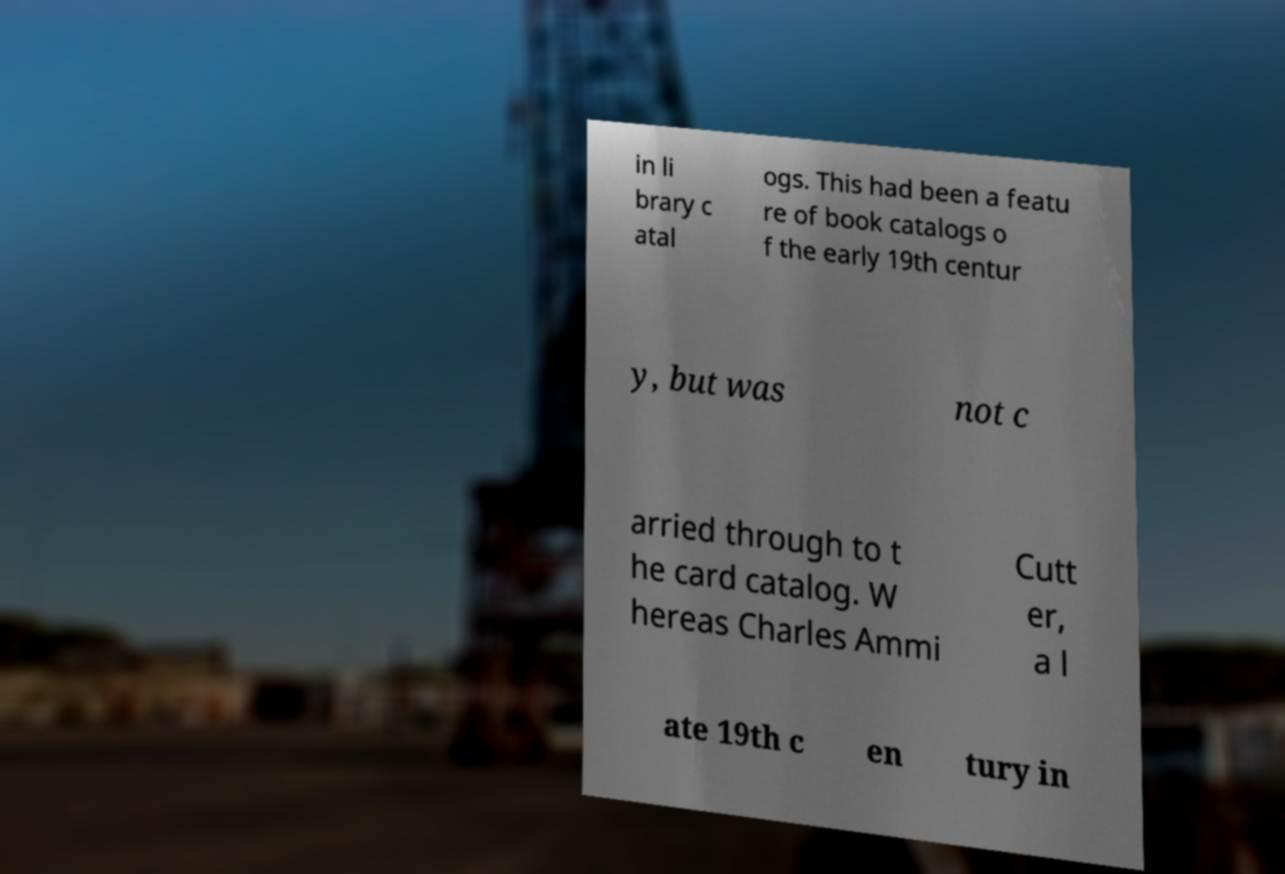What messages or text are displayed in this image? I need them in a readable, typed format. in li brary c atal ogs. This had been a featu re of book catalogs o f the early 19th centur y, but was not c arried through to t he card catalog. W hereas Charles Ammi Cutt er, a l ate 19th c en tury in 